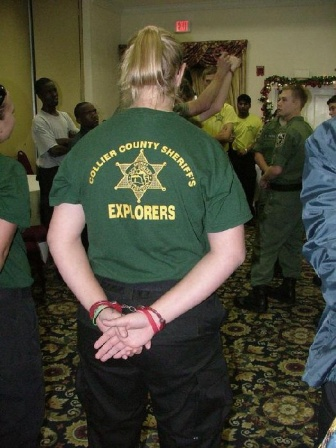Can you describe the activities or interactions taking place in the image? The image shows a group of people gathered in a room with beige walls and a floral carpet. At the center is a person wearing a green t-shirt that reads 'Collier County Sheriff's Explorers' with their hands clasped behind them, seemingly observing the group. The group of people in the background appear engaged in conversation or listening to someone speak, suggesting a social or training event. The presence of a Christmas tree and festive decorations imply that it's a holiday-related gathering, possibly including a mixture of casual interactions and structured activities like discussions or presentations. 